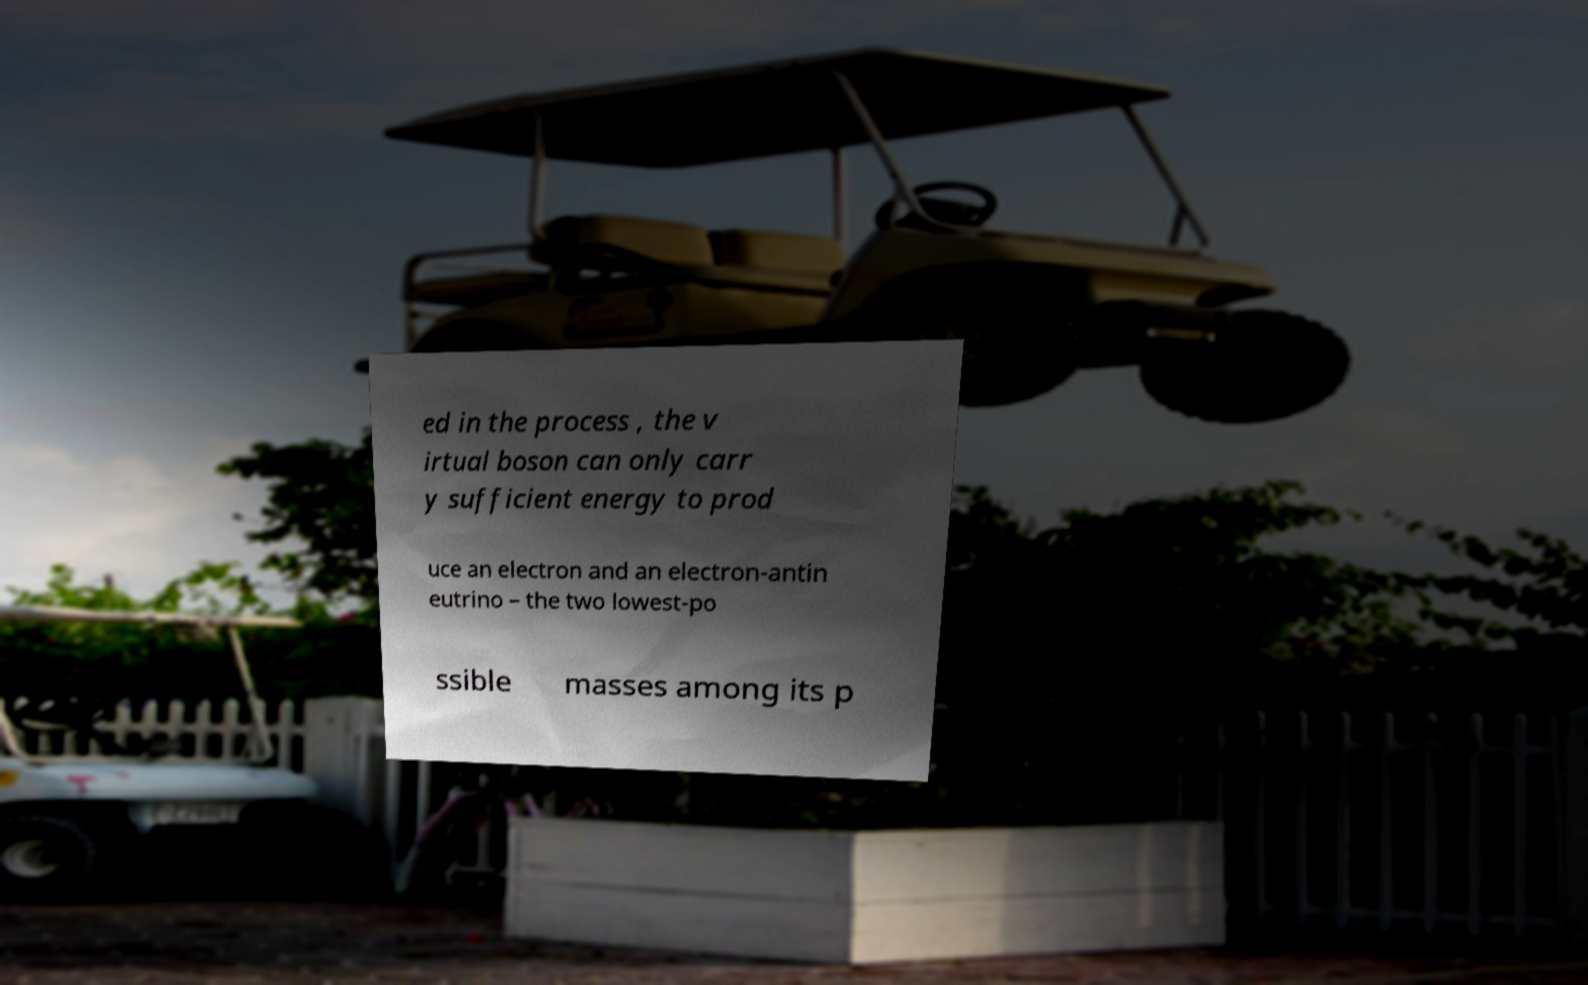Can you read and provide the text displayed in the image?This photo seems to have some interesting text. Can you extract and type it out for me? ed in the process , the v irtual boson can only carr y sufficient energy to prod uce an electron and an electron-antin eutrino – the two lowest-po ssible masses among its p 